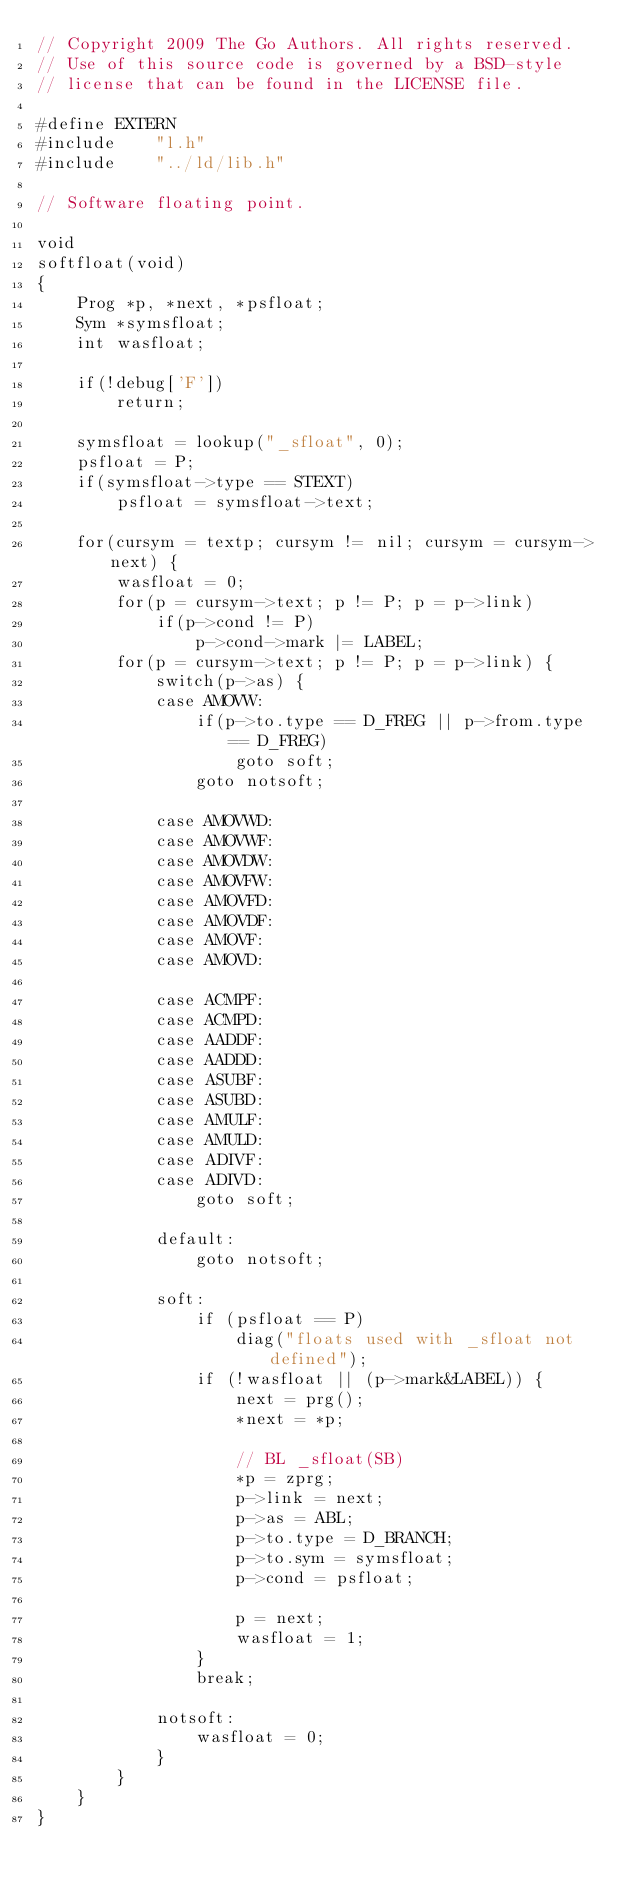<code> <loc_0><loc_0><loc_500><loc_500><_C_>// Copyright 2009 The Go Authors. All rights reserved.
// Use of this source code is governed by a BSD-style
// license that can be found in the LICENSE file.

#define	EXTERN
#include	"l.h"
#include	"../ld/lib.h"

// Software floating point.

void
softfloat(void)
{
	Prog *p, *next, *psfloat;
	Sym *symsfloat;
	int wasfloat;

	if(!debug['F'])
		return;

	symsfloat = lookup("_sfloat", 0);
	psfloat = P;
	if(symsfloat->type == STEXT)
		psfloat = symsfloat->text;

	for(cursym = textp; cursym != nil; cursym = cursym->next) {
		wasfloat = 0;
		for(p = cursym->text; p != P; p = p->link)
			if(p->cond != P)
				p->cond->mark |= LABEL;
		for(p = cursym->text; p != P; p = p->link) {
			switch(p->as) {
			case AMOVW:
				if(p->to.type == D_FREG || p->from.type == D_FREG)
					goto soft;
				goto notsoft;

			case AMOVWD:
			case AMOVWF:
			case AMOVDW:
			case AMOVFW:
			case AMOVFD:
			case AMOVDF:
			case AMOVF:
			case AMOVD:

			case ACMPF:
			case ACMPD:
			case AADDF:
			case AADDD:
			case ASUBF:
			case ASUBD:
			case AMULF:
			case AMULD:
			case ADIVF:
			case ADIVD:
				goto soft;

			default:
				goto notsoft;

			soft:
				if (psfloat == P)
					diag("floats used with _sfloat not defined");
				if (!wasfloat || (p->mark&LABEL)) {
					next = prg();
					*next = *p;
	
					// BL _sfloat(SB)
					*p = zprg;
					p->link = next;
					p->as = ABL;
	 				p->to.type = D_BRANCH;
					p->to.sym = symsfloat;
					p->cond = psfloat;
	
					p = next;
					wasfloat = 1;
				}
				break;

			notsoft:
				wasfloat = 0;
			}
		}
	}
}
</code> 